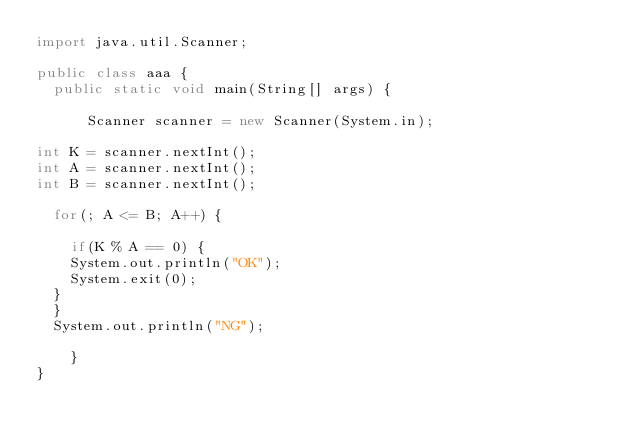<code> <loc_0><loc_0><loc_500><loc_500><_Java_>import java.util.Scanner;

public class aaa {
	public static void main(String[] args) {

		  Scanner scanner = new Scanner(System.in);

int K = scanner.nextInt();
int A = scanner.nextInt();
int B = scanner.nextInt();

	for(; A <= B; A++) {

    if(K % A == 0) {
    System.out.println("OK");
    System.exit(0);
  }
	}
	System.out.println("NG");

	  }
}
</code> 